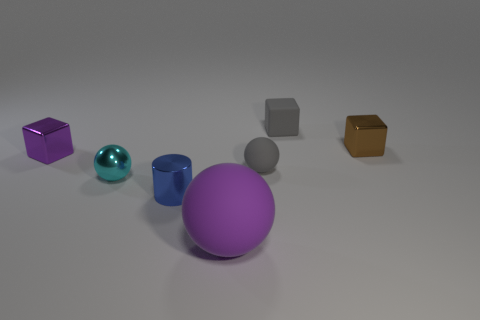What is the size of the gray thing that is in front of the small gray rubber thing that is behind the purple thing that is behind the purple rubber object?
Your answer should be very brief. Small. What material is the object that is to the left of the small ball that is on the left side of the shiny cylinder made of?
Give a very brief answer. Metal. Are there any large cyan rubber things that have the same shape as the tiny brown object?
Provide a short and direct response. No. What is the shape of the cyan thing?
Offer a very short reply. Sphere. What is the material of the sphere that is in front of the blue shiny cylinder left of the purple thing on the right side of the tiny cyan metallic thing?
Your answer should be compact. Rubber. Are there more tiny purple metal cubes that are in front of the purple metallic block than tiny yellow matte cylinders?
Keep it short and to the point. No. There is a purple block that is the same size as the brown metallic thing; what is its material?
Provide a succinct answer. Metal. Is there a gray ball that has the same size as the blue metallic cylinder?
Keep it short and to the point. Yes. There is a metallic object that is to the right of the tiny matte sphere; what is its size?
Your response must be concise. Small. The brown cube is what size?
Offer a very short reply. Small. 